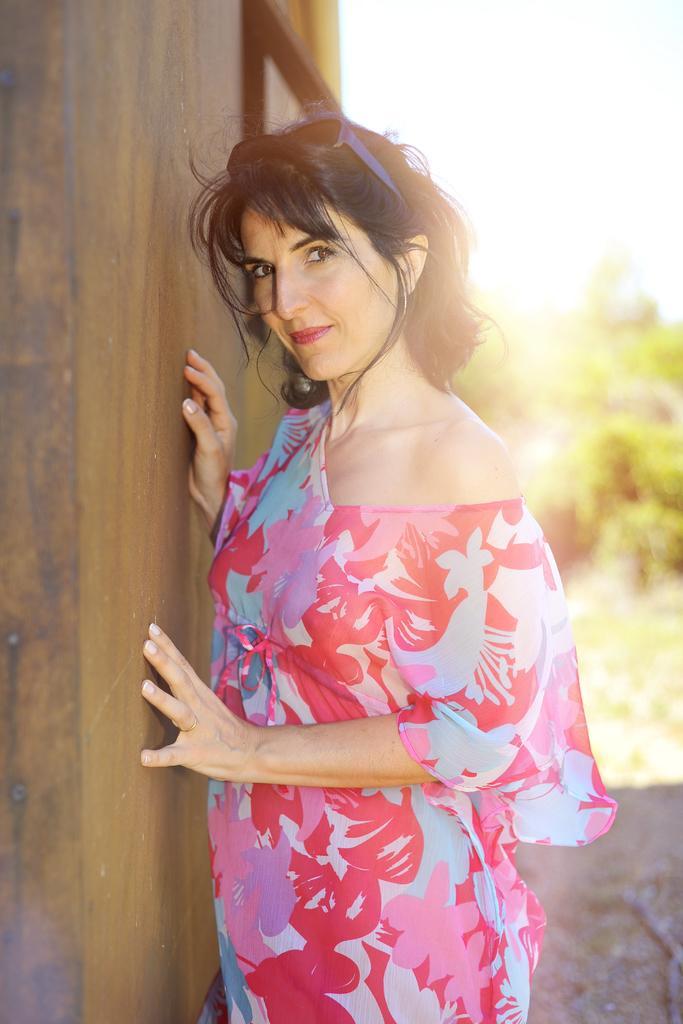Could you give a brief overview of what you see in this image? In the image there is a woman in red dress standing beside a wooden wall, in the back there are trees on the land and above its sky. 